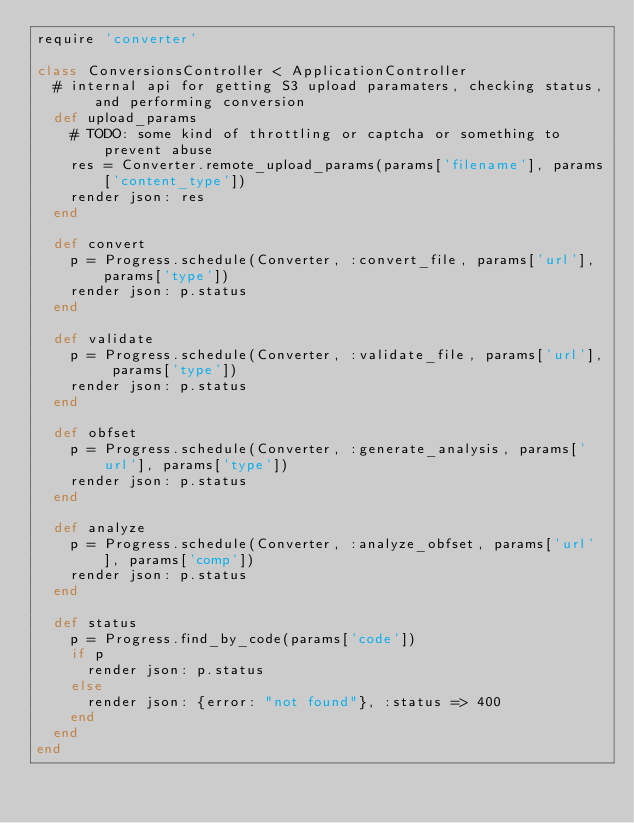Convert code to text. <code><loc_0><loc_0><loc_500><loc_500><_Ruby_>require 'converter'

class ConversionsController < ApplicationController
  # internal api for getting S3 upload paramaters, checking status, and performing conversion
  def upload_params
    # TODO: some kind of throttling or captcha or something to prevent abuse
    res = Converter.remote_upload_params(params['filename'], params['content_type'])
    render json: res
  end
  
  def convert
    p = Progress.schedule(Converter, :convert_file, params['url'], params['type'])
    render json: p.status
  end
  
  def validate
    p = Progress.schedule(Converter, :validate_file, params['url'], params['type'])
    render json: p.status
  end

  def obfset
    p = Progress.schedule(Converter, :generate_analysis, params['url'], params['type'])
    render json: p.status
  end

  def analyze
    p = Progress.schedule(Converter, :analyze_obfset, params['url'], params['comp'])
    render json: p.status
  end
  
  def status
    p = Progress.find_by_code(params['code'])
    if p
      render json: p.status
    else
      render json: {error: "not found"}, :status => 400
    end
  end
end
</code> 